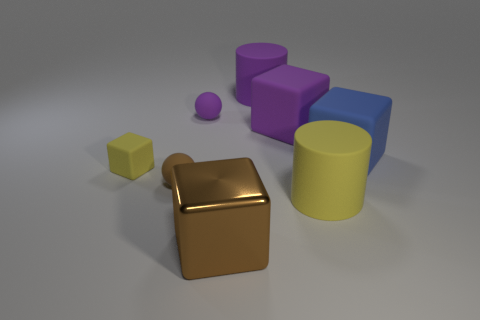Add 1 large yellow rubber cylinders. How many objects exist? 9 Subtract all cylinders. How many objects are left? 6 Add 1 red cubes. How many red cubes exist? 1 Subtract 0 blue cylinders. How many objects are left? 8 Subtract all large brown matte cylinders. Subtract all metal blocks. How many objects are left? 7 Add 2 small blocks. How many small blocks are left? 3 